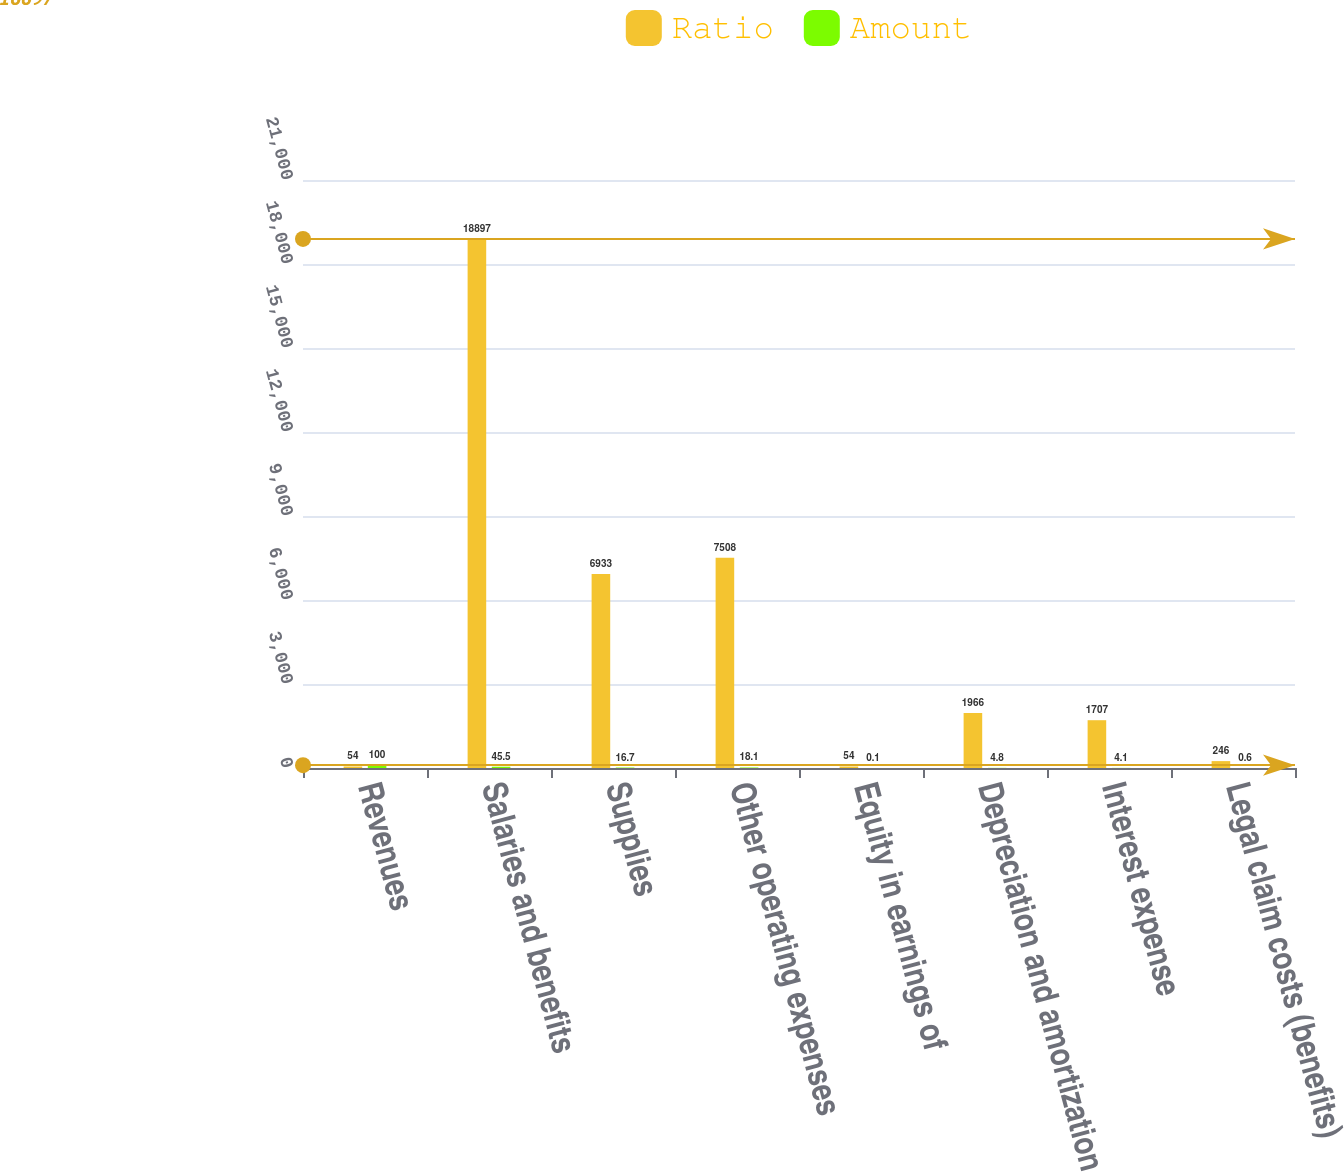<chart> <loc_0><loc_0><loc_500><loc_500><stacked_bar_chart><ecel><fcel>Revenues<fcel>Salaries and benefits<fcel>Supplies<fcel>Other operating expenses<fcel>Equity in earnings of<fcel>Depreciation and amortization<fcel>Interest expense<fcel>Legal claim costs (benefits)<nl><fcel>Ratio<fcel>54<fcel>18897<fcel>6933<fcel>7508<fcel>54<fcel>1966<fcel>1707<fcel>246<nl><fcel>Amount<fcel>100<fcel>45.5<fcel>16.7<fcel>18.1<fcel>0.1<fcel>4.8<fcel>4.1<fcel>0.6<nl></chart> 